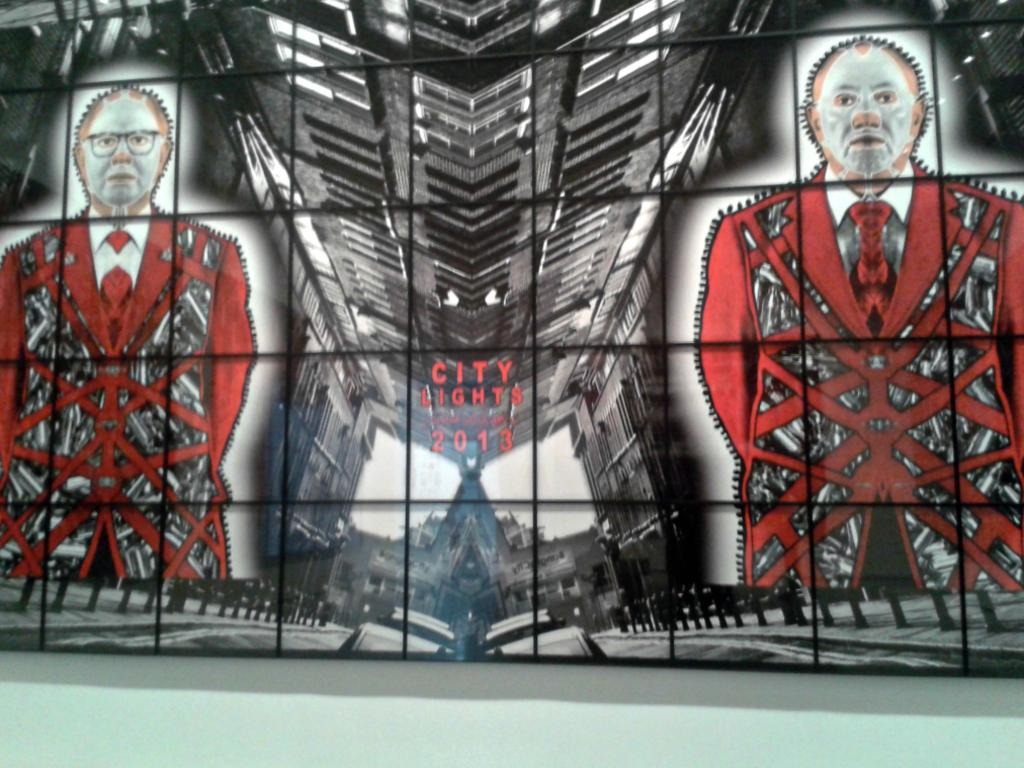What type of wall is present in the image? There is a glass wall in the image. What is depicted on the glass wall? The glass wall has an image of animation pictures. Are there any words written on the glass wall? Yes, the words "City Lights 2013" are written on the glass wall. Can you see a bear interacting with the animation pictures on the glass wall? There is no bear present in the image, and the glass wall only displays animation pictures. 